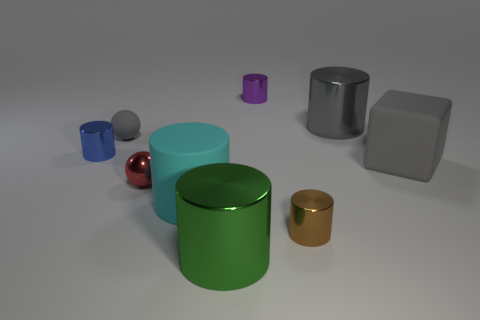Are there any pair of objects that might belong to the same set or category based on their properties? Yes, the two cylinders, one in green and the other in silver to its left, seem to be a part of the same category, likely belonging to a set of cylindrical objects made from metal. Their similar shapes and reflective properties suggest a common categorization, differing only in their size and color. 